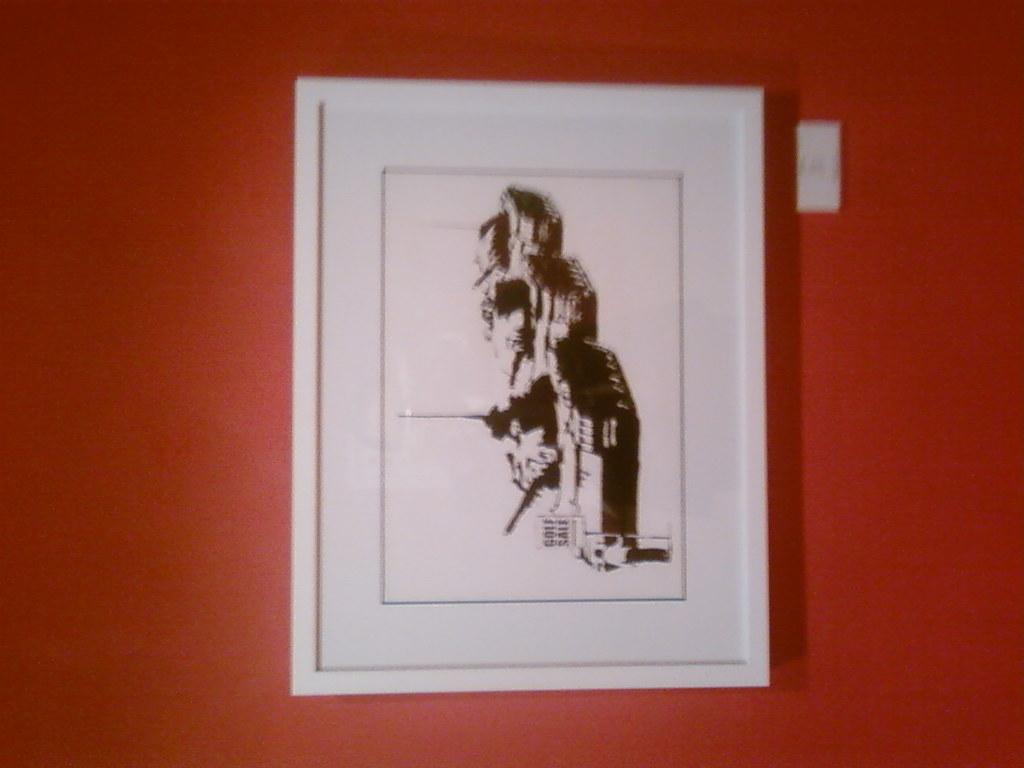What is the main object in the image? There is a frame in the image. What is the frame attached to? The frame is attached to a brown surface. What color is the frame? The frame is white in color. How many cherries are hanging from the frame in the image? There are no cherries present in the image; it only features a white frame attached to a brown surface. 